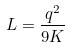<formula> <loc_0><loc_0><loc_500><loc_500>L = \frac { q ^ { 2 } } { 9 K }</formula> 